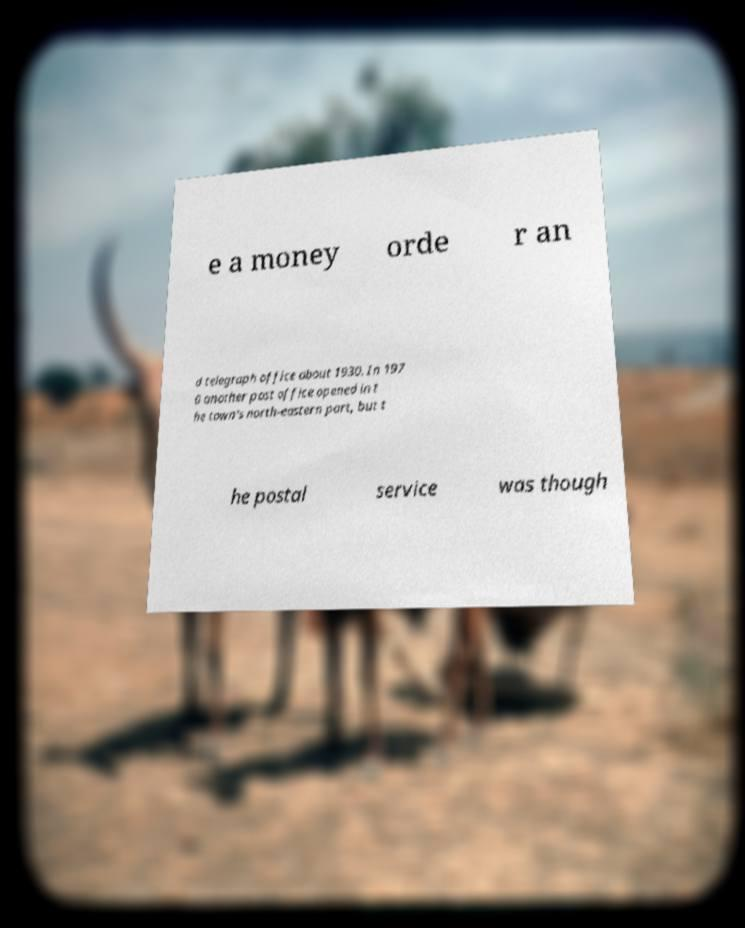Please read and relay the text visible in this image. What does it say? e a money orde r an d telegraph office about 1930. In 197 0 another post office opened in t he town's north-eastern part, but t he postal service was though 